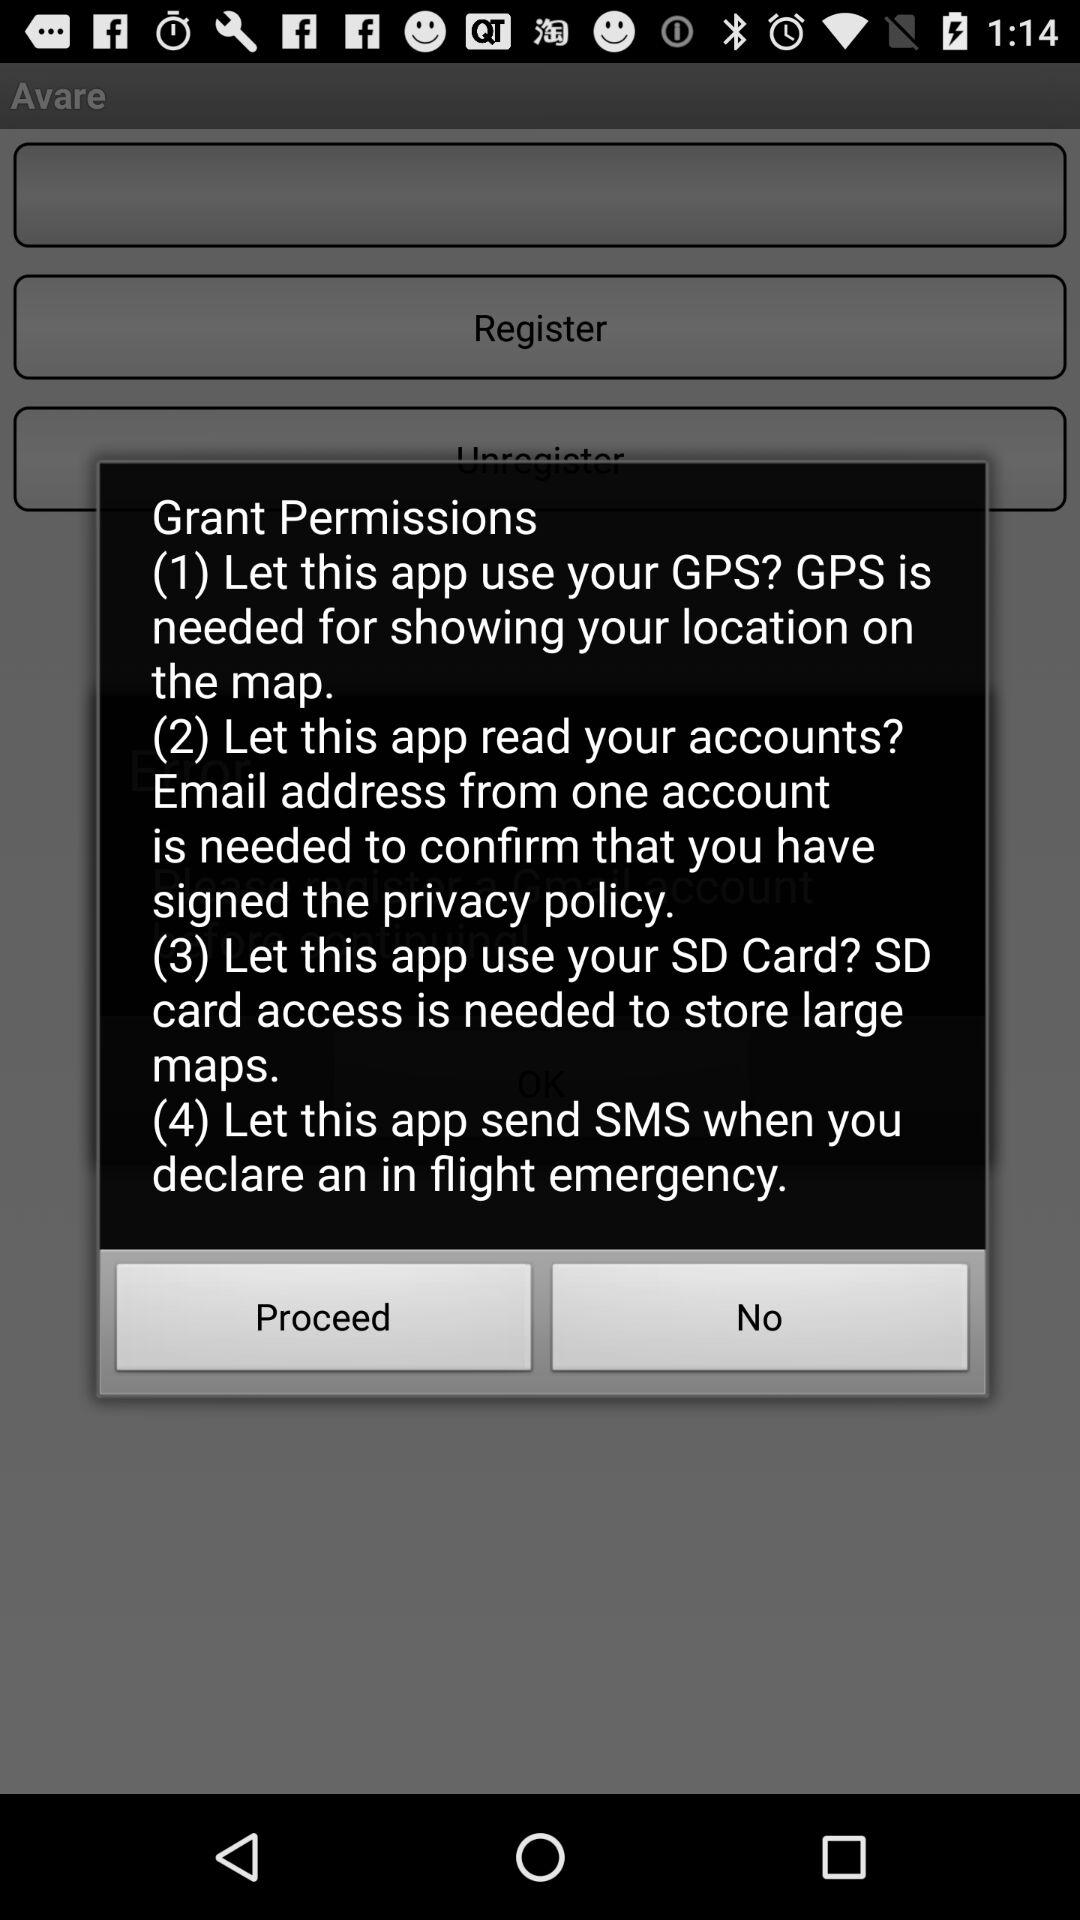What is the need for GPS? GPS is needed for showing your location on the map. 